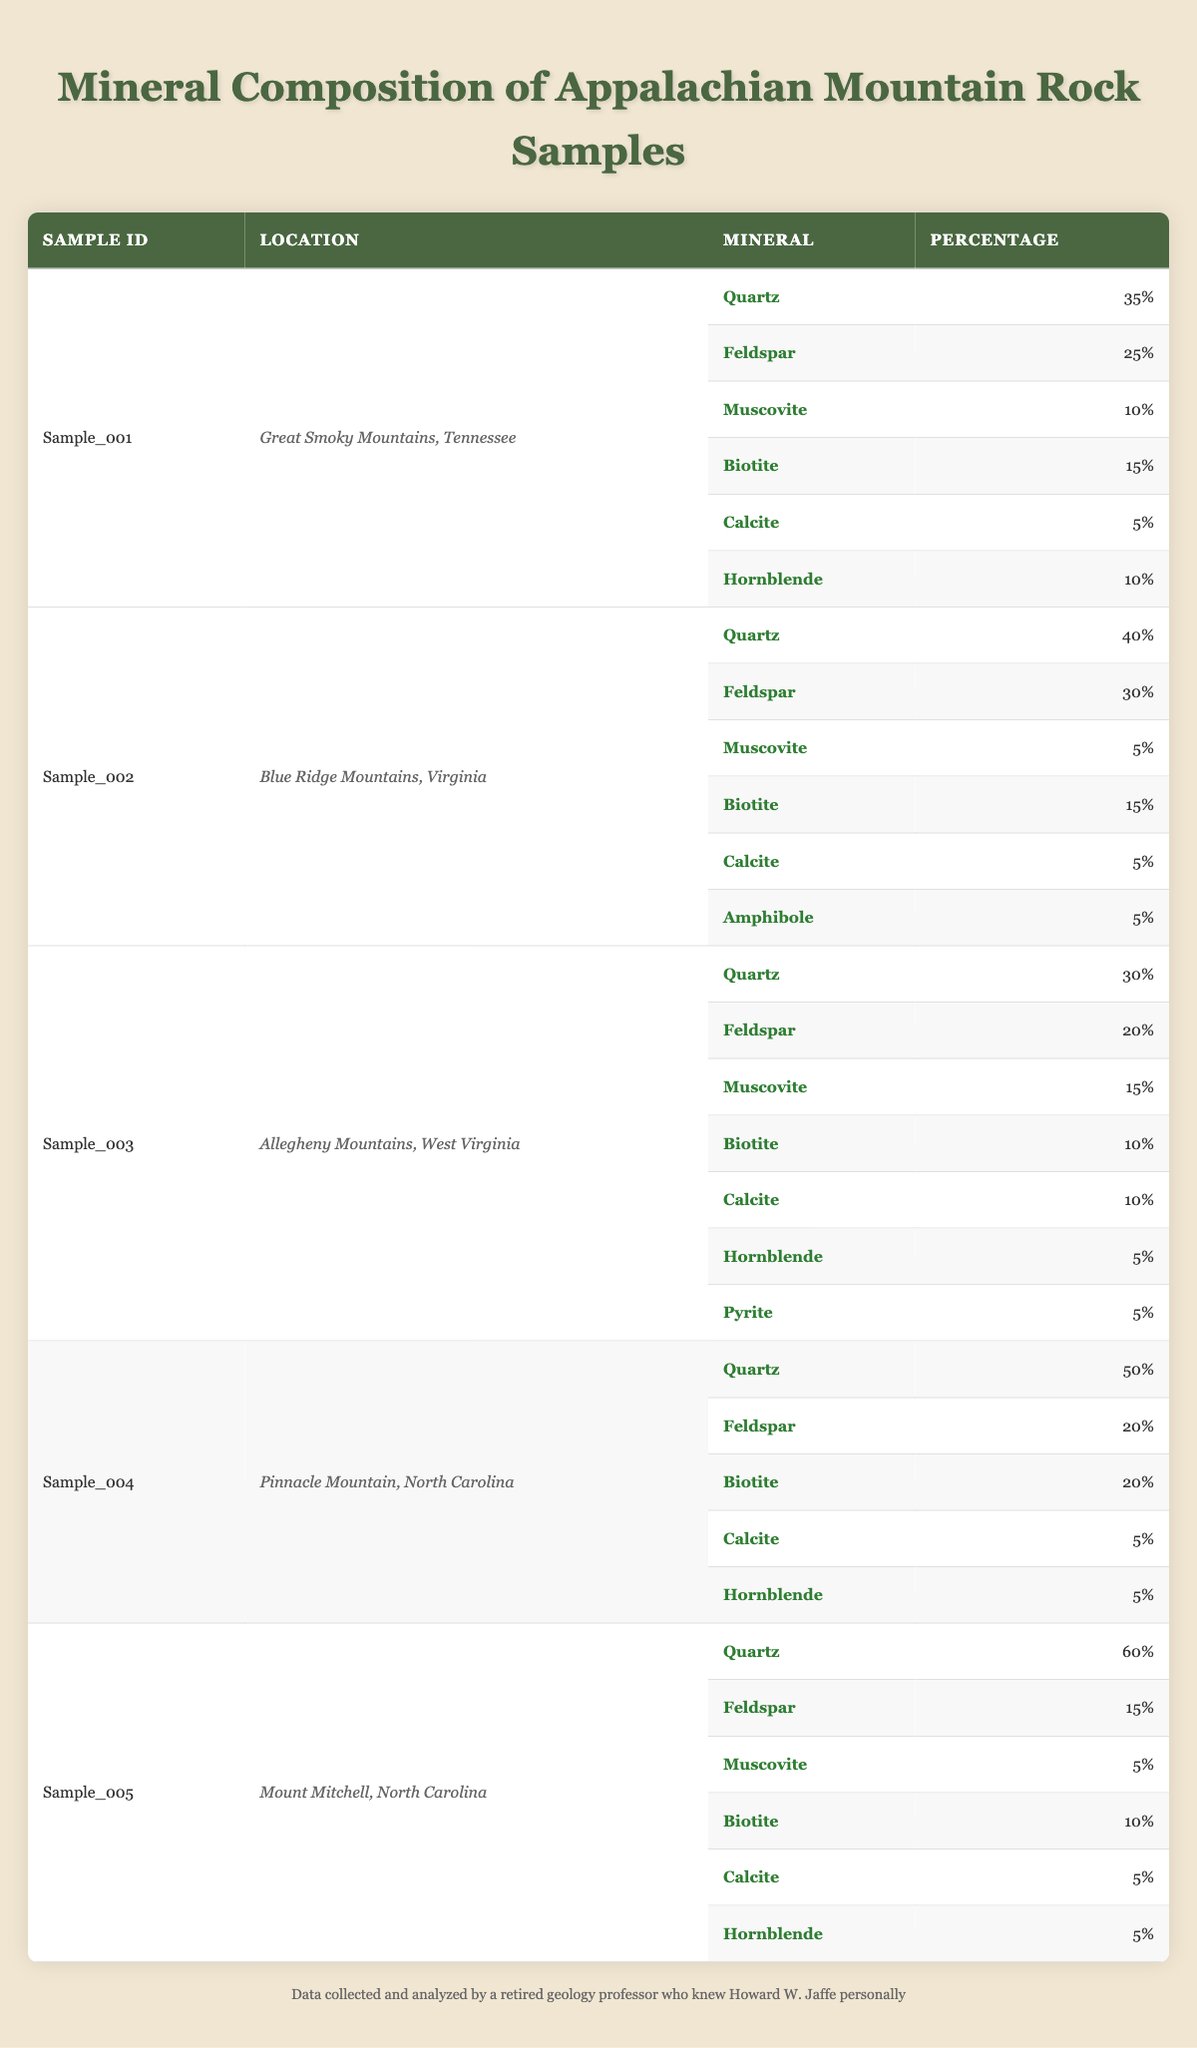What is the mineral with the highest percentage in Sample_004? In Sample_004, the minerals listed are Quartz (50%), Feldspar (20%), Biotite (20%), Calcite (5%), and Hornblende (5%). The mineral with the highest percentage is Quartz at 50%.
Answer: Quartz Which rock sample has the highest total percentage of Muscovite? The total percentages of Muscovite are as follows: Sample_001 has 10%, Sample_002 has 5%, Sample_003 has 15%, Sample_004 has 0%, and Sample_005 has 5%. Sample_003 has the highest total percentage of Muscovite at 15%.
Answer: Sample_003 Is there any sample where Calcite is present in more than 5%? Looking at the table, Calcite appears in Sample_001 (5%), Sample_002 (5%), Sample_003 (10%), Sample_004 (5%), and Sample_005 (5%). Sample_003 contains Calcite at 10%, which is greater than 5%. Therefore, yes, there is a sample with more than 5% Calcite.
Answer: Yes What is the average percentage of Feldspar across all samples? The percentages of Feldspar are: Sample_001 (25%), Sample_002 (30%), Sample_003 (20%), Sample_004 (20%), and Sample_005 (15%). Summing these gives (25 + 30 + 20 + 20 + 15) = 110, and dividing by the number of samples (5) gives an average of 110/5 = 22%.
Answer: 22% Which location has the highest percentage of Biotite? The percentages of Biotite are: Sample_001 (15%), Sample_002 (15%), Sample_003 (10%), Sample_004 (20%), and Sample_005 (10%). Sample_004 has the highest percentage of Biotite at 20%.
Answer: Pinnacle Mountain, North Carolina How many minerals are present in Sample_005? In Sample_005, the listed minerals are: Quartz (60%), Feldspar (15%), Muscovite (5%), Biotite (10%), Calcite (5%), and Hornblende (5%). There are a total of 6 different minerals in Sample_005.
Answer: 6 What is the total percentage of all minerals in Sample_002? The mineral percentages in Sample_002 are Quartz (40%), Feldspar (30%), Muscovite (5%), Biotite (15%), Calcite (5%), and Amphibole (5%). Summing these gives (40 + 30 + 5 + 15 + 5 + 5) = 100%, which confirms that all minerals completely account for the sample.
Answer: 100% Does the Allegheny Mountains sample contain Pyrite? Looking at Sample_003, which is from the Allegheny Mountains, it lists Pyrite as one of the minerals with a percentage of 5%. Hence, it does contain Pyrite.
Answer: Yes 